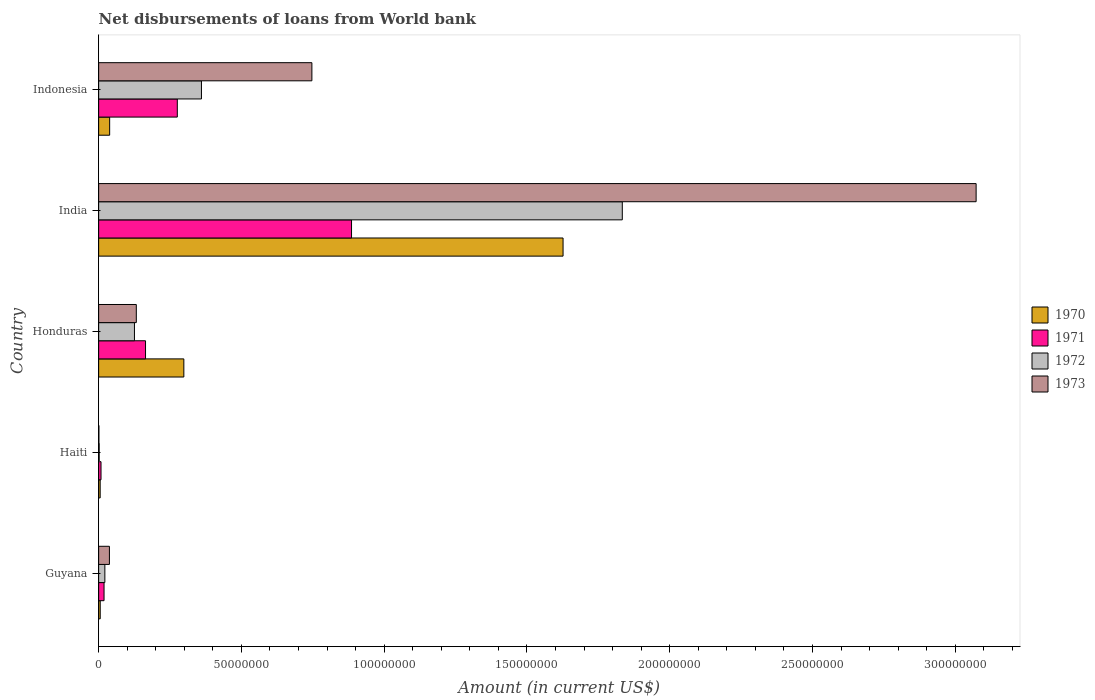Are the number of bars per tick equal to the number of legend labels?
Offer a very short reply. Yes. Are the number of bars on each tick of the Y-axis equal?
Provide a succinct answer. Yes. How many bars are there on the 1st tick from the bottom?
Provide a short and direct response. 4. What is the label of the 5th group of bars from the top?
Provide a succinct answer. Guyana. What is the amount of loan disbursed from World Bank in 1971 in Guyana?
Give a very brief answer. 1.89e+06. Across all countries, what is the maximum amount of loan disbursed from World Bank in 1973?
Provide a short and direct response. 3.07e+08. Across all countries, what is the minimum amount of loan disbursed from World Bank in 1970?
Ensure brevity in your answer.  5.38e+05. In which country was the amount of loan disbursed from World Bank in 1970 maximum?
Keep it short and to the point. India. In which country was the amount of loan disbursed from World Bank in 1973 minimum?
Provide a short and direct response. Haiti. What is the total amount of loan disbursed from World Bank in 1970 in the graph?
Provide a succinct answer. 1.97e+08. What is the difference between the amount of loan disbursed from World Bank in 1971 in Haiti and that in India?
Your response must be concise. -8.77e+07. What is the difference between the amount of loan disbursed from World Bank in 1973 in Guyana and the amount of loan disbursed from World Bank in 1972 in Honduras?
Make the answer very short. -8.76e+06. What is the average amount of loan disbursed from World Bank in 1971 per country?
Your answer should be compact. 2.71e+07. What is the difference between the amount of loan disbursed from World Bank in 1973 and amount of loan disbursed from World Bank in 1971 in Haiti?
Keep it short and to the point. -7.36e+05. In how many countries, is the amount of loan disbursed from World Bank in 1971 greater than 140000000 US$?
Your response must be concise. 0. What is the ratio of the amount of loan disbursed from World Bank in 1973 in Guyana to that in India?
Make the answer very short. 0.01. Is the amount of loan disbursed from World Bank in 1971 in Guyana less than that in India?
Keep it short and to the point. Yes. Is the difference between the amount of loan disbursed from World Bank in 1973 in Haiti and India greater than the difference between the amount of loan disbursed from World Bank in 1971 in Haiti and India?
Your answer should be very brief. No. What is the difference between the highest and the second highest amount of loan disbursed from World Bank in 1970?
Offer a very short reply. 1.33e+08. What is the difference between the highest and the lowest amount of loan disbursed from World Bank in 1970?
Keep it short and to the point. 1.62e+08. In how many countries, is the amount of loan disbursed from World Bank in 1972 greater than the average amount of loan disbursed from World Bank in 1972 taken over all countries?
Ensure brevity in your answer.  1. What does the 4th bar from the top in Indonesia represents?
Give a very brief answer. 1970. Is it the case that in every country, the sum of the amount of loan disbursed from World Bank in 1970 and amount of loan disbursed from World Bank in 1972 is greater than the amount of loan disbursed from World Bank in 1971?
Offer a very short reply. No. Does the graph contain any zero values?
Provide a short and direct response. No. Where does the legend appear in the graph?
Make the answer very short. Center right. How are the legend labels stacked?
Ensure brevity in your answer.  Vertical. What is the title of the graph?
Your response must be concise. Net disbursements of loans from World bank. Does "1973" appear as one of the legend labels in the graph?
Provide a succinct answer. Yes. What is the label or title of the X-axis?
Provide a succinct answer. Amount (in current US$). What is the label or title of the Y-axis?
Offer a terse response. Country. What is the Amount (in current US$) in 1970 in Guyana?
Keep it short and to the point. 5.53e+05. What is the Amount (in current US$) in 1971 in Guyana?
Your answer should be very brief. 1.89e+06. What is the Amount (in current US$) in 1972 in Guyana?
Offer a terse response. 2.18e+06. What is the Amount (in current US$) in 1973 in Guyana?
Keep it short and to the point. 3.78e+06. What is the Amount (in current US$) in 1970 in Haiti?
Provide a succinct answer. 5.38e+05. What is the Amount (in current US$) of 1971 in Haiti?
Ensure brevity in your answer.  8.34e+05. What is the Amount (in current US$) in 1972 in Haiti?
Your response must be concise. 1.96e+05. What is the Amount (in current US$) in 1973 in Haiti?
Offer a terse response. 9.80e+04. What is the Amount (in current US$) of 1970 in Honduras?
Offer a very short reply. 2.98e+07. What is the Amount (in current US$) of 1971 in Honduras?
Your response must be concise. 1.64e+07. What is the Amount (in current US$) in 1972 in Honduras?
Your response must be concise. 1.25e+07. What is the Amount (in current US$) in 1973 in Honduras?
Your answer should be compact. 1.32e+07. What is the Amount (in current US$) in 1970 in India?
Provide a short and direct response. 1.63e+08. What is the Amount (in current US$) in 1971 in India?
Provide a short and direct response. 8.86e+07. What is the Amount (in current US$) in 1972 in India?
Offer a very short reply. 1.83e+08. What is the Amount (in current US$) of 1973 in India?
Offer a terse response. 3.07e+08. What is the Amount (in current US$) of 1970 in Indonesia?
Your answer should be very brief. 3.86e+06. What is the Amount (in current US$) in 1971 in Indonesia?
Keep it short and to the point. 2.76e+07. What is the Amount (in current US$) in 1972 in Indonesia?
Offer a very short reply. 3.60e+07. What is the Amount (in current US$) of 1973 in Indonesia?
Offer a terse response. 7.47e+07. Across all countries, what is the maximum Amount (in current US$) in 1970?
Your response must be concise. 1.63e+08. Across all countries, what is the maximum Amount (in current US$) in 1971?
Offer a terse response. 8.86e+07. Across all countries, what is the maximum Amount (in current US$) of 1972?
Make the answer very short. 1.83e+08. Across all countries, what is the maximum Amount (in current US$) of 1973?
Your answer should be compact. 3.07e+08. Across all countries, what is the minimum Amount (in current US$) in 1970?
Offer a very short reply. 5.38e+05. Across all countries, what is the minimum Amount (in current US$) of 1971?
Your answer should be compact. 8.34e+05. Across all countries, what is the minimum Amount (in current US$) of 1972?
Your answer should be compact. 1.96e+05. Across all countries, what is the minimum Amount (in current US$) in 1973?
Ensure brevity in your answer.  9.80e+04. What is the total Amount (in current US$) in 1970 in the graph?
Keep it short and to the point. 1.97e+08. What is the total Amount (in current US$) of 1971 in the graph?
Keep it short and to the point. 1.35e+08. What is the total Amount (in current US$) in 1972 in the graph?
Ensure brevity in your answer.  2.34e+08. What is the total Amount (in current US$) of 1973 in the graph?
Provide a succinct answer. 3.99e+08. What is the difference between the Amount (in current US$) in 1970 in Guyana and that in Haiti?
Provide a short and direct response. 1.50e+04. What is the difference between the Amount (in current US$) in 1971 in Guyana and that in Haiti?
Keep it short and to the point. 1.06e+06. What is the difference between the Amount (in current US$) of 1972 in Guyana and that in Haiti?
Your answer should be very brief. 1.98e+06. What is the difference between the Amount (in current US$) of 1973 in Guyana and that in Haiti?
Offer a very short reply. 3.68e+06. What is the difference between the Amount (in current US$) of 1970 in Guyana and that in Honduras?
Offer a terse response. -2.93e+07. What is the difference between the Amount (in current US$) in 1971 in Guyana and that in Honduras?
Give a very brief answer. -1.45e+07. What is the difference between the Amount (in current US$) in 1972 in Guyana and that in Honduras?
Ensure brevity in your answer.  -1.04e+07. What is the difference between the Amount (in current US$) of 1973 in Guyana and that in Honduras?
Ensure brevity in your answer.  -9.42e+06. What is the difference between the Amount (in current US$) of 1970 in Guyana and that in India?
Offer a terse response. -1.62e+08. What is the difference between the Amount (in current US$) of 1971 in Guyana and that in India?
Keep it short and to the point. -8.67e+07. What is the difference between the Amount (in current US$) of 1972 in Guyana and that in India?
Offer a very short reply. -1.81e+08. What is the difference between the Amount (in current US$) of 1973 in Guyana and that in India?
Offer a terse response. -3.04e+08. What is the difference between the Amount (in current US$) in 1970 in Guyana and that in Indonesia?
Keep it short and to the point. -3.31e+06. What is the difference between the Amount (in current US$) of 1971 in Guyana and that in Indonesia?
Make the answer very short. -2.57e+07. What is the difference between the Amount (in current US$) of 1972 in Guyana and that in Indonesia?
Your answer should be very brief. -3.38e+07. What is the difference between the Amount (in current US$) in 1973 in Guyana and that in Indonesia?
Give a very brief answer. -7.09e+07. What is the difference between the Amount (in current US$) in 1970 in Haiti and that in Honduras?
Provide a short and direct response. -2.93e+07. What is the difference between the Amount (in current US$) in 1971 in Haiti and that in Honduras?
Offer a terse response. -1.56e+07. What is the difference between the Amount (in current US$) of 1972 in Haiti and that in Honduras?
Make the answer very short. -1.23e+07. What is the difference between the Amount (in current US$) of 1973 in Haiti and that in Honduras?
Offer a very short reply. -1.31e+07. What is the difference between the Amount (in current US$) of 1970 in Haiti and that in India?
Your answer should be compact. -1.62e+08. What is the difference between the Amount (in current US$) in 1971 in Haiti and that in India?
Offer a very short reply. -8.77e+07. What is the difference between the Amount (in current US$) in 1972 in Haiti and that in India?
Offer a terse response. -1.83e+08. What is the difference between the Amount (in current US$) of 1973 in Haiti and that in India?
Your response must be concise. -3.07e+08. What is the difference between the Amount (in current US$) in 1970 in Haiti and that in Indonesia?
Give a very brief answer. -3.32e+06. What is the difference between the Amount (in current US$) in 1971 in Haiti and that in Indonesia?
Provide a short and direct response. -2.67e+07. What is the difference between the Amount (in current US$) in 1972 in Haiti and that in Indonesia?
Your response must be concise. -3.58e+07. What is the difference between the Amount (in current US$) of 1973 in Haiti and that in Indonesia?
Give a very brief answer. -7.46e+07. What is the difference between the Amount (in current US$) in 1970 in Honduras and that in India?
Your response must be concise. -1.33e+08. What is the difference between the Amount (in current US$) of 1971 in Honduras and that in India?
Provide a short and direct response. -7.21e+07. What is the difference between the Amount (in current US$) of 1972 in Honduras and that in India?
Give a very brief answer. -1.71e+08. What is the difference between the Amount (in current US$) in 1973 in Honduras and that in India?
Make the answer very short. -2.94e+08. What is the difference between the Amount (in current US$) in 1970 in Honduras and that in Indonesia?
Your answer should be compact. 2.60e+07. What is the difference between the Amount (in current US$) in 1971 in Honduras and that in Indonesia?
Ensure brevity in your answer.  -1.11e+07. What is the difference between the Amount (in current US$) in 1972 in Honduras and that in Indonesia?
Your answer should be compact. -2.35e+07. What is the difference between the Amount (in current US$) of 1973 in Honduras and that in Indonesia?
Provide a succinct answer. -6.15e+07. What is the difference between the Amount (in current US$) in 1970 in India and that in Indonesia?
Give a very brief answer. 1.59e+08. What is the difference between the Amount (in current US$) in 1971 in India and that in Indonesia?
Keep it short and to the point. 6.10e+07. What is the difference between the Amount (in current US$) of 1972 in India and that in Indonesia?
Your answer should be very brief. 1.47e+08. What is the difference between the Amount (in current US$) of 1973 in India and that in Indonesia?
Make the answer very short. 2.33e+08. What is the difference between the Amount (in current US$) of 1970 in Guyana and the Amount (in current US$) of 1971 in Haiti?
Your response must be concise. -2.81e+05. What is the difference between the Amount (in current US$) in 1970 in Guyana and the Amount (in current US$) in 1972 in Haiti?
Provide a short and direct response. 3.57e+05. What is the difference between the Amount (in current US$) in 1970 in Guyana and the Amount (in current US$) in 1973 in Haiti?
Offer a terse response. 4.55e+05. What is the difference between the Amount (in current US$) of 1971 in Guyana and the Amount (in current US$) of 1972 in Haiti?
Provide a short and direct response. 1.70e+06. What is the difference between the Amount (in current US$) of 1971 in Guyana and the Amount (in current US$) of 1973 in Haiti?
Provide a short and direct response. 1.80e+06. What is the difference between the Amount (in current US$) in 1972 in Guyana and the Amount (in current US$) in 1973 in Haiti?
Make the answer very short. 2.08e+06. What is the difference between the Amount (in current US$) in 1970 in Guyana and the Amount (in current US$) in 1971 in Honduras?
Give a very brief answer. -1.59e+07. What is the difference between the Amount (in current US$) of 1970 in Guyana and the Amount (in current US$) of 1972 in Honduras?
Provide a short and direct response. -1.20e+07. What is the difference between the Amount (in current US$) of 1970 in Guyana and the Amount (in current US$) of 1973 in Honduras?
Keep it short and to the point. -1.26e+07. What is the difference between the Amount (in current US$) in 1971 in Guyana and the Amount (in current US$) in 1972 in Honduras?
Your response must be concise. -1.07e+07. What is the difference between the Amount (in current US$) in 1971 in Guyana and the Amount (in current US$) in 1973 in Honduras?
Make the answer very short. -1.13e+07. What is the difference between the Amount (in current US$) of 1972 in Guyana and the Amount (in current US$) of 1973 in Honduras?
Keep it short and to the point. -1.10e+07. What is the difference between the Amount (in current US$) in 1970 in Guyana and the Amount (in current US$) in 1971 in India?
Provide a succinct answer. -8.80e+07. What is the difference between the Amount (in current US$) in 1970 in Guyana and the Amount (in current US$) in 1972 in India?
Ensure brevity in your answer.  -1.83e+08. What is the difference between the Amount (in current US$) of 1970 in Guyana and the Amount (in current US$) of 1973 in India?
Offer a very short reply. -3.07e+08. What is the difference between the Amount (in current US$) of 1971 in Guyana and the Amount (in current US$) of 1972 in India?
Keep it short and to the point. -1.81e+08. What is the difference between the Amount (in current US$) in 1971 in Guyana and the Amount (in current US$) in 1973 in India?
Keep it short and to the point. -3.05e+08. What is the difference between the Amount (in current US$) in 1972 in Guyana and the Amount (in current US$) in 1973 in India?
Provide a succinct answer. -3.05e+08. What is the difference between the Amount (in current US$) in 1970 in Guyana and the Amount (in current US$) in 1971 in Indonesia?
Your answer should be very brief. -2.70e+07. What is the difference between the Amount (in current US$) in 1970 in Guyana and the Amount (in current US$) in 1972 in Indonesia?
Ensure brevity in your answer.  -3.55e+07. What is the difference between the Amount (in current US$) in 1970 in Guyana and the Amount (in current US$) in 1973 in Indonesia?
Provide a short and direct response. -7.41e+07. What is the difference between the Amount (in current US$) of 1971 in Guyana and the Amount (in current US$) of 1972 in Indonesia?
Provide a short and direct response. -3.41e+07. What is the difference between the Amount (in current US$) in 1971 in Guyana and the Amount (in current US$) in 1973 in Indonesia?
Your answer should be compact. -7.28e+07. What is the difference between the Amount (in current US$) of 1972 in Guyana and the Amount (in current US$) of 1973 in Indonesia?
Provide a short and direct response. -7.25e+07. What is the difference between the Amount (in current US$) in 1970 in Haiti and the Amount (in current US$) in 1971 in Honduras?
Provide a short and direct response. -1.59e+07. What is the difference between the Amount (in current US$) in 1970 in Haiti and the Amount (in current US$) in 1972 in Honduras?
Your answer should be very brief. -1.20e+07. What is the difference between the Amount (in current US$) in 1970 in Haiti and the Amount (in current US$) in 1973 in Honduras?
Your answer should be compact. -1.27e+07. What is the difference between the Amount (in current US$) of 1971 in Haiti and the Amount (in current US$) of 1972 in Honduras?
Your answer should be very brief. -1.17e+07. What is the difference between the Amount (in current US$) of 1971 in Haiti and the Amount (in current US$) of 1973 in Honduras?
Give a very brief answer. -1.24e+07. What is the difference between the Amount (in current US$) in 1972 in Haiti and the Amount (in current US$) in 1973 in Honduras?
Your response must be concise. -1.30e+07. What is the difference between the Amount (in current US$) in 1970 in Haiti and the Amount (in current US$) in 1971 in India?
Give a very brief answer. -8.80e+07. What is the difference between the Amount (in current US$) in 1970 in Haiti and the Amount (in current US$) in 1972 in India?
Ensure brevity in your answer.  -1.83e+08. What is the difference between the Amount (in current US$) of 1970 in Haiti and the Amount (in current US$) of 1973 in India?
Your answer should be very brief. -3.07e+08. What is the difference between the Amount (in current US$) of 1971 in Haiti and the Amount (in current US$) of 1972 in India?
Your answer should be very brief. -1.83e+08. What is the difference between the Amount (in current US$) in 1971 in Haiti and the Amount (in current US$) in 1973 in India?
Your answer should be compact. -3.06e+08. What is the difference between the Amount (in current US$) of 1972 in Haiti and the Amount (in current US$) of 1973 in India?
Give a very brief answer. -3.07e+08. What is the difference between the Amount (in current US$) of 1970 in Haiti and the Amount (in current US$) of 1971 in Indonesia?
Offer a terse response. -2.70e+07. What is the difference between the Amount (in current US$) of 1970 in Haiti and the Amount (in current US$) of 1972 in Indonesia?
Provide a succinct answer. -3.55e+07. What is the difference between the Amount (in current US$) in 1970 in Haiti and the Amount (in current US$) in 1973 in Indonesia?
Your response must be concise. -7.41e+07. What is the difference between the Amount (in current US$) of 1971 in Haiti and the Amount (in current US$) of 1972 in Indonesia?
Give a very brief answer. -3.52e+07. What is the difference between the Amount (in current US$) of 1971 in Haiti and the Amount (in current US$) of 1973 in Indonesia?
Provide a succinct answer. -7.38e+07. What is the difference between the Amount (in current US$) in 1972 in Haiti and the Amount (in current US$) in 1973 in Indonesia?
Ensure brevity in your answer.  -7.45e+07. What is the difference between the Amount (in current US$) in 1970 in Honduras and the Amount (in current US$) in 1971 in India?
Your answer should be very brief. -5.87e+07. What is the difference between the Amount (in current US$) of 1970 in Honduras and the Amount (in current US$) of 1972 in India?
Make the answer very short. -1.54e+08. What is the difference between the Amount (in current US$) in 1970 in Honduras and the Amount (in current US$) in 1973 in India?
Your answer should be compact. -2.77e+08. What is the difference between the Amount (in current US$) of 1971 in Honduras and the Amount (in current US$) of 1972 in India?
Your answer should be very brief. -1.67e+08. What is the difference between the Amount (in current US$) of 1971 in Honduras and the Amount (in current US$) of 1973 in India?
Your response must be concise. -2.91e+08. What is the difference between the Amount (in current US$) of 1972 in Honduras and the Amount (in current US$) of 1973 in India?
Ensure brevity in your answer.  -2.95e+08. What is the difference between the Amount (in current US$) in 1970 in Honduras and the Amount (in current US$) in 1971 in Indonesia?
Keep it short and to the point. 2.29e+06. What is the difference between the Amount (in current US$) of 1970 in Honduras and the Amount (in current US$) of 1972 in Indonesia?
Provide a succinct answer. -6.17e+06. What is the difference between the Amount (in current US$) in 1970 in Honduras and the Amount (in current US$) in 1973 in Indonesia?
Your response must be concise. -4.48e+07. What is the difference between the Amount (in current US$) of 1971 in Honduras and the Amount (in current US$) of 1972 in Indonesia?
Offer a terse response. -1.96e+07. What is the difference between the Amount (in current US$) of 1971 in Honduras and the Amount (in current US$) of 1973 in Indonesia?
Give a very brief answer. -5.83e+07. What is the difference between the Amount (in current US$) of 1972 in Honduras and the Amount (in current US$) of 1973 in Indonesia?
Provide a short and direct response. -6.21e+07. What is the difference between the Amount (in current US$) in 1970 in India and the Amount (in current US$) in 1971 in Indonesia?
Keep it short and to the point. 1.35e+08. What is the difference between the Amount (in current US$) of 1970 in India and the Amount (in current US$) of 1972 in Indonesia?
Offer a very short reply. 1.27e+08. What is the difference between the Amount (in current US$) in 1970 in India and the Amount (in current US$) in 1973 in Indonesia?
Make the answer very short. 8.80e+07. What is the difference between the Amount (in current US$) of 1971 in India and the Amount (in current US$) of 1972 in Indonesia?
Make the answer very short. 5.26e+07. What is the difference between the Amount (in current US$) in 1971 in India and the Amount (in current US$) in 1973 in Indonesia?
Ensure brevity in your answer.  1.39e+07. What is the difference between the Amount (in current US$) in 1972 in India and the Amount (in current US$) in 1973 in Indonesia?
Offer a terse response. 1.09e+08. What is the average Amount (in current US$) in 1970 per country?
Keep it short and to the point. 3.95e+07. What is the average Amount (in current US$) in 1971 per country?
Give a very brief answer. 2.71e+07. What is the average Amount (in current US$) of 1972 per country?
Give a very brief answer. 4.69e+07. What is the average Amount (in current US$) of 1973 per country?
Your answer should be very brief. 7.98e+07. What is the difference between the Amount (in current US$) in 1970 and Amount (in current US$) in 1971 in Guyana?
Ensure brevity in your answer.  -1.34e+06. What is the difference between the Amount (in current US$) of 1970 and Amount (in current US$) of 1972 in Guyana?
Give a very brief answer. -1.63e+06. What is the difference between the Amount (in current US$) in 1970 and Amount (in current US$) in 1973 in Guyana?
Make the answer very short. -3.23e+06. What is the difference between the Amount (in current US$) in 1971 and Amount (in current US$) in 1972 in Guyana?
Your response must be concise. -2.87e+05. What is the difference between the Amount (in current US$) of 1971 and Amount (in current US$) of 1973 in Guyana?
Your response must be concise. -1.89e+06. What is the difference between the Amount (in current US$) in 1972 and Amount (in current US$) in 1973 in Guyana?
Your response must be concise. -1.60e+06. What is the difference between the Amount (in current US$) of 1970 and Amount (in current US$) of 1971 in Haiti?
Make the answer very short. -2.96e+05. What is the difference between the Amount (in current US$) of 1970 and Amount (in current US$) of 1972 in Haiti?
Your answer should be compact. 3.42e+05. What is the difference between the Amount (in current US$) of 1970 and Amount (in current US$) of 1973 in Haiti?
Offer a terse response. 4.40e+05. What is the difference between the Amount (in current US$) of 1971 and Amount (in current US$) of 1972 in Haiti?
Keep it short and to the point. 6.38e+05. What is the difference between the Amount (in current US$) of 1971 and Amount (in current US$) of 1973 in Haiti?
Your answer should be compact. 7.36e+05. What is the difference between the Amount (in current US$) in 1972 and Amount (in current US$) in 1973 in Haiti?
Keep it short and to the point. 9.80e+04. What is the difference between the Amount (in current US$) of 1970 and Amount (in current US$) of 1971 in Honduras?
Offer a very short reply. 1.34e+07. What is the difference between the Amount (in current US$) of 1970 and Amount (in current US$) of 1972 in Honduras?
Provide a succinct answer. 1.73e+07. What is the difference between the Amount (in current US$) in 1970 and Amount (in current US$) in 1973 in Honduras?
Ensure brevity in your answer.  1.66e+07. What is the difference between the Amount (in current US$) of 1971 and Amount (in current US$) of 1972 in Honduras?
Offer a very short reply. 3.88e+06. What is the difference between the Amount (in current US$) of 1971 and Amount (in current US$) of 1973 in Honduras?
Provide a short and direct response. 3.23e+06. What is the difference between the Amount (in current US$) in 1972 and Amount (in current US$) in 1973 in Honduras?
Offer a terse response. -6.51e+05. What is the difference between the Amount (in current US$) of 1970 and Amount (in current US$) of 1971 in India?
Offer a terse response. 7.41e+07. What is the difference between the Amount (in current US$) of 1970 and Amount (in current US$) of 1972 in India?
Your answer should be compact. -2.07e+07. What is the difference between the Amount (in current US$) in 1970 and Amount (in current US$) in 1973 in India?
Provide a short and direct response. -1.45e+08. What is the difference between the Amount (in current US$) of 1971 and Amount (in current US$) of 1972 in India?
Provide a short and direct response. -9.48e+07. What is the difference between the Amount (in current US$) in 1971 and Amount (in current US$) in 1973 in India?
Make the answer very short. -2.19e+08. What is the difference between the Amount (in current US$) of 1972 and Amount (in current US$) of 1973 in India?
Ensure brevity in your answer.  -1.24e+08. What is the difference between the Amount (in current US$) in 1970 and Amount (in current US$) in 1971 in Indonesia?
Make the answer very short. -2.37e+07. What is the difference between the Amount (in current US$) of 1970 and Amount (in current US$) of 1972 in Indonesia?
Your response must be concise. -3.21e+07. What is the difference between the Amount (in current US$) in 1970 and Amount (in current US$) in 1973 in Indonesia?
Offer a terse response. -7.08e+07. What is the difference between the Amount (in current US$) of 1971 and Amount (in current US$) of 1972 in Indonesia?
Provide a succinct answer. -8.45e+06. What is the difference between the Amount (in current US$) of 1971 and Amount (in current US$) of 1973 in Indonesia?
Your answer should be very brief. -4.71e+07. What is the difference between the Amount (in current US$) in 1972 and Amount (in current US$) in 1973 in Indonesia?
Provide a short and direct response. -3.87e+07. What is the ratio of the Amount (in current US$) in 1970 in Guyana to that in Haiti?
Your answer should be compact. 1.03. What is the ratio of the Amount (in current US$) in 1971 in Guyana to that in Haiti?
Your response must be concise. 2.27. What is the ratio of the Amount (in current US$) in 1972 in Guyana to that in Haiti?
Your response must be concise. 11.12. What is the ratio of the Amount (in current US$) in 1973 in Guyana to that in Haiti?
Give a very brief answer. 38.56. What is the ratio of the Amount (in current US$) in 1970 in Guyana to that in Honduras?
Your answer should be compact. 0.02. What is the ratio of the Amount (in current US$) of 1971 in Guyana to that in Honduras?
Keep it short and to the point. 0.12. What is the ratio of the Amount (in current US$) of 1972 in Guyana to that in Honduras?
Your response must be concise. 0.17. What is the ratio of the Amount (in current US$) of 1973 in Guyana to that in Honduras?
Give a very brief answer. 0.29. What is the ratio of the Amount (in current US$) in 1970 in Guyana to that in India?
Your answer should be compact. 0. What is the ratio of the Amount (in current US$) of 1971 in Guyana to that in India?
Offer a very short reply. 0.02. What is the ratio of the Amount (in current US$) of 1972 in Guyana to that in India?
Keep it short and to the point. 0.01. What is the ratio of the Amount (in current US$) of 1973 in Guyana to that in India?
Keep it short and to the point. 0.01. What is the ratio of the Amount (in current US$) in 1970 in Guyana to that in Indonesia?
Your response must be concise. 0.14. What is the ratio of the Amount (in current US$) in 1971 in Guyana to that in Indonesia?
Your response must be concise. 0.07. What is the ratio of the Amount (in current US$) in 1972 in Guyana to that in Indonesia?
Your response must be concise. 0.06. What is the ratio of the Amount (in current US$) in 1973 in Guyana to that in Indonesia?
Your response must be concise. 0.05. What is the ratio of the Amount (in current US$) of 1970 in Haiti to that in Honduras?
Offer a terse response. 0.02. What is the ratio of the Amount (in current US$) of 1971 in Haiti to that in Honduras?
Your answer should be compact. 0.05. What is the ratio of the Amount (in current US$) of 1972 in Haiti to that in Honduras?
Ensure brevity in your answer.  0.02. What is the ratio of the Amount (in current US$) of 1973 in Haiti to that in Honduras?
Provide a short and direct response. 0.01. What is the ratio of the Amount (in current US$) of 1970 in Haiti to that in India?
Your answer should be very brief. 0. What is the ratio of the Amount (in current US$) in 1971 in Haiti to that in India?
Your response must be concise. 0.01. What is the ratio of the Amount (in current US$) in 1972 in Haiti to that in India?
Your answer should be very brief. 0. What is the ratio of the Amount (in current US$) in 1970 in Haiti to that in Indonesia?
Keep it short and to the point. 0.14. What is the ratio of the Amount (in current US$) in 1971 in Haiti to that in Indonesia?
Offer a terse response. 0.03. What is the ratio of the Amount (in current US$) of 1972 in Haiti to that in Indonesia?
Provide a succinct answer. 0.01. What is the ratio of the Amount (in current US$) of 1973 in Haiti to that in Indonesia?
Make the answer very short. 0. What is the ratio of the Amount (in current US$) in 1970 in Honduras to that in India?
Offer a very short reply. 0.18. What is the ratio of the Amount (in current US$) of 1971 in Honduras to that in India?
Your response must be concise. 0.19. What is the ratio of the Amount (in current US$) of 1972 in Honduras to that in India?
Your answer should be very brief. 0.07. What is the ratio of the Amount (in current US$) of 1973 in Honduras to that in India?
Keep it short and to the point. 0.04. What is the ratio of the Amount (in current US$) in 1970 in Honduras to that in Indonesia?
Provide a short and direct response. 7.73. What is the ratio of the Amount (in current US$) in 1971 in Honduras to that in Indonesia?
Keep it short and to the point. 0.6. What is the ratio of the Amount (in current US$) of 1972 in Honduras to that in Indonesia?
Offer a very short reply. 0.35. What is the ratio of the Amount (in current US$) of 1973 in Honduras to that in Indonesia?
Your response must be concise. 0.18. What is the ratio of the Amount (in current US$) of 1970 in India to that in Indonesia?
Your response must be concise. 42.14. What is the ratio of the Amount (in current US$) of 1971 in India to that in Indonesia?
Provide a succinct answer. 3.21. What is the ratio of the Amount (in current US$) of 1972 in India to that in Indonesia?
Your answer should be compact. 5.09. What is the ratio of the Amount (in current US$) in 1973 in India to that in Indonesia?
Offer a terse response. 4.11. What is the difference between the highest and the second highest Amount (in current US$) in 1970?
Your answer should be compact. 1.33e+08. What is the difference between the highest and the second highest Amount (in current US$) of 1971?
Provide a succinct answer. 6.10e+07. What is the difference between the highest and the second highest Amount (in current US$) of 1972?
Your response must be concise. 1.47e+08. What is the difference between the highest and the second highest Amount (in current US$) of 1973?
Provide a short and direct response. 2.33e+08. What is the difference between the highest and the lowest Amount (in current US$) in 1970?
Your response must be concise. 1.62e+08. What is the difference between the highest and the lowest Amount (in current US$) in 1971?
Your response must be concise. 8.77e+07. What is the difference between the highest and the lowest Amount (in current US$) in 1972?
Provide a short and direct response. 1.83e+08. What is the difference between the highest and the lowest Amount (in current US$) of 1973?
Give a very brief answer. 3.07e+08. 